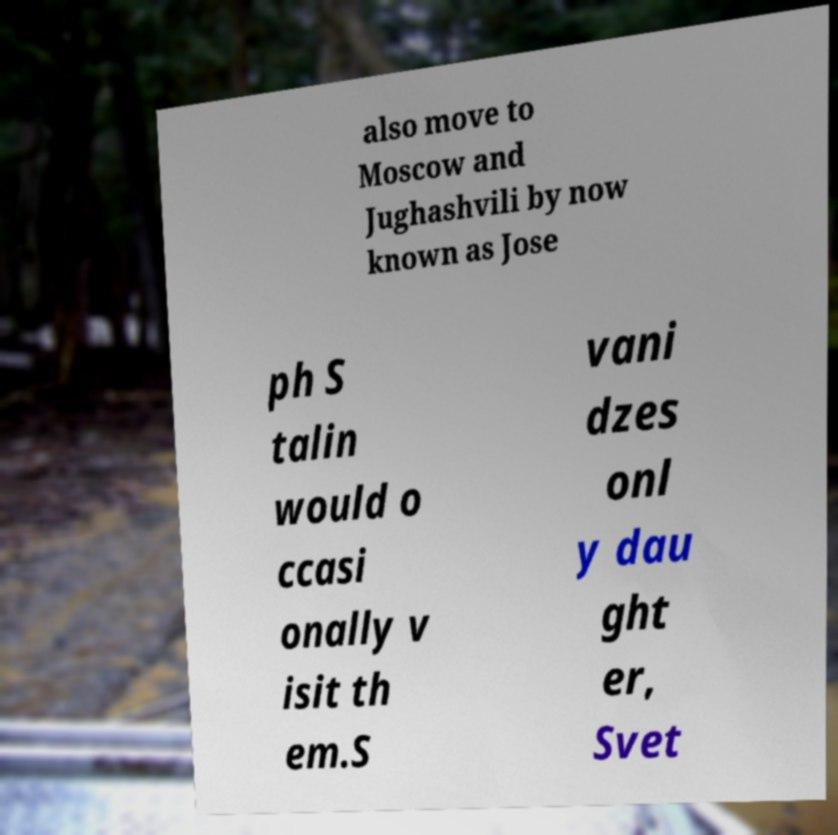Can you accurately transcribe the text from the provided image for me? also move to Moscow and Jughashvili by now known as Jose ph S talin would o ccasi onally v isit th em.S vani dzes onl y dau ght er, Svet 